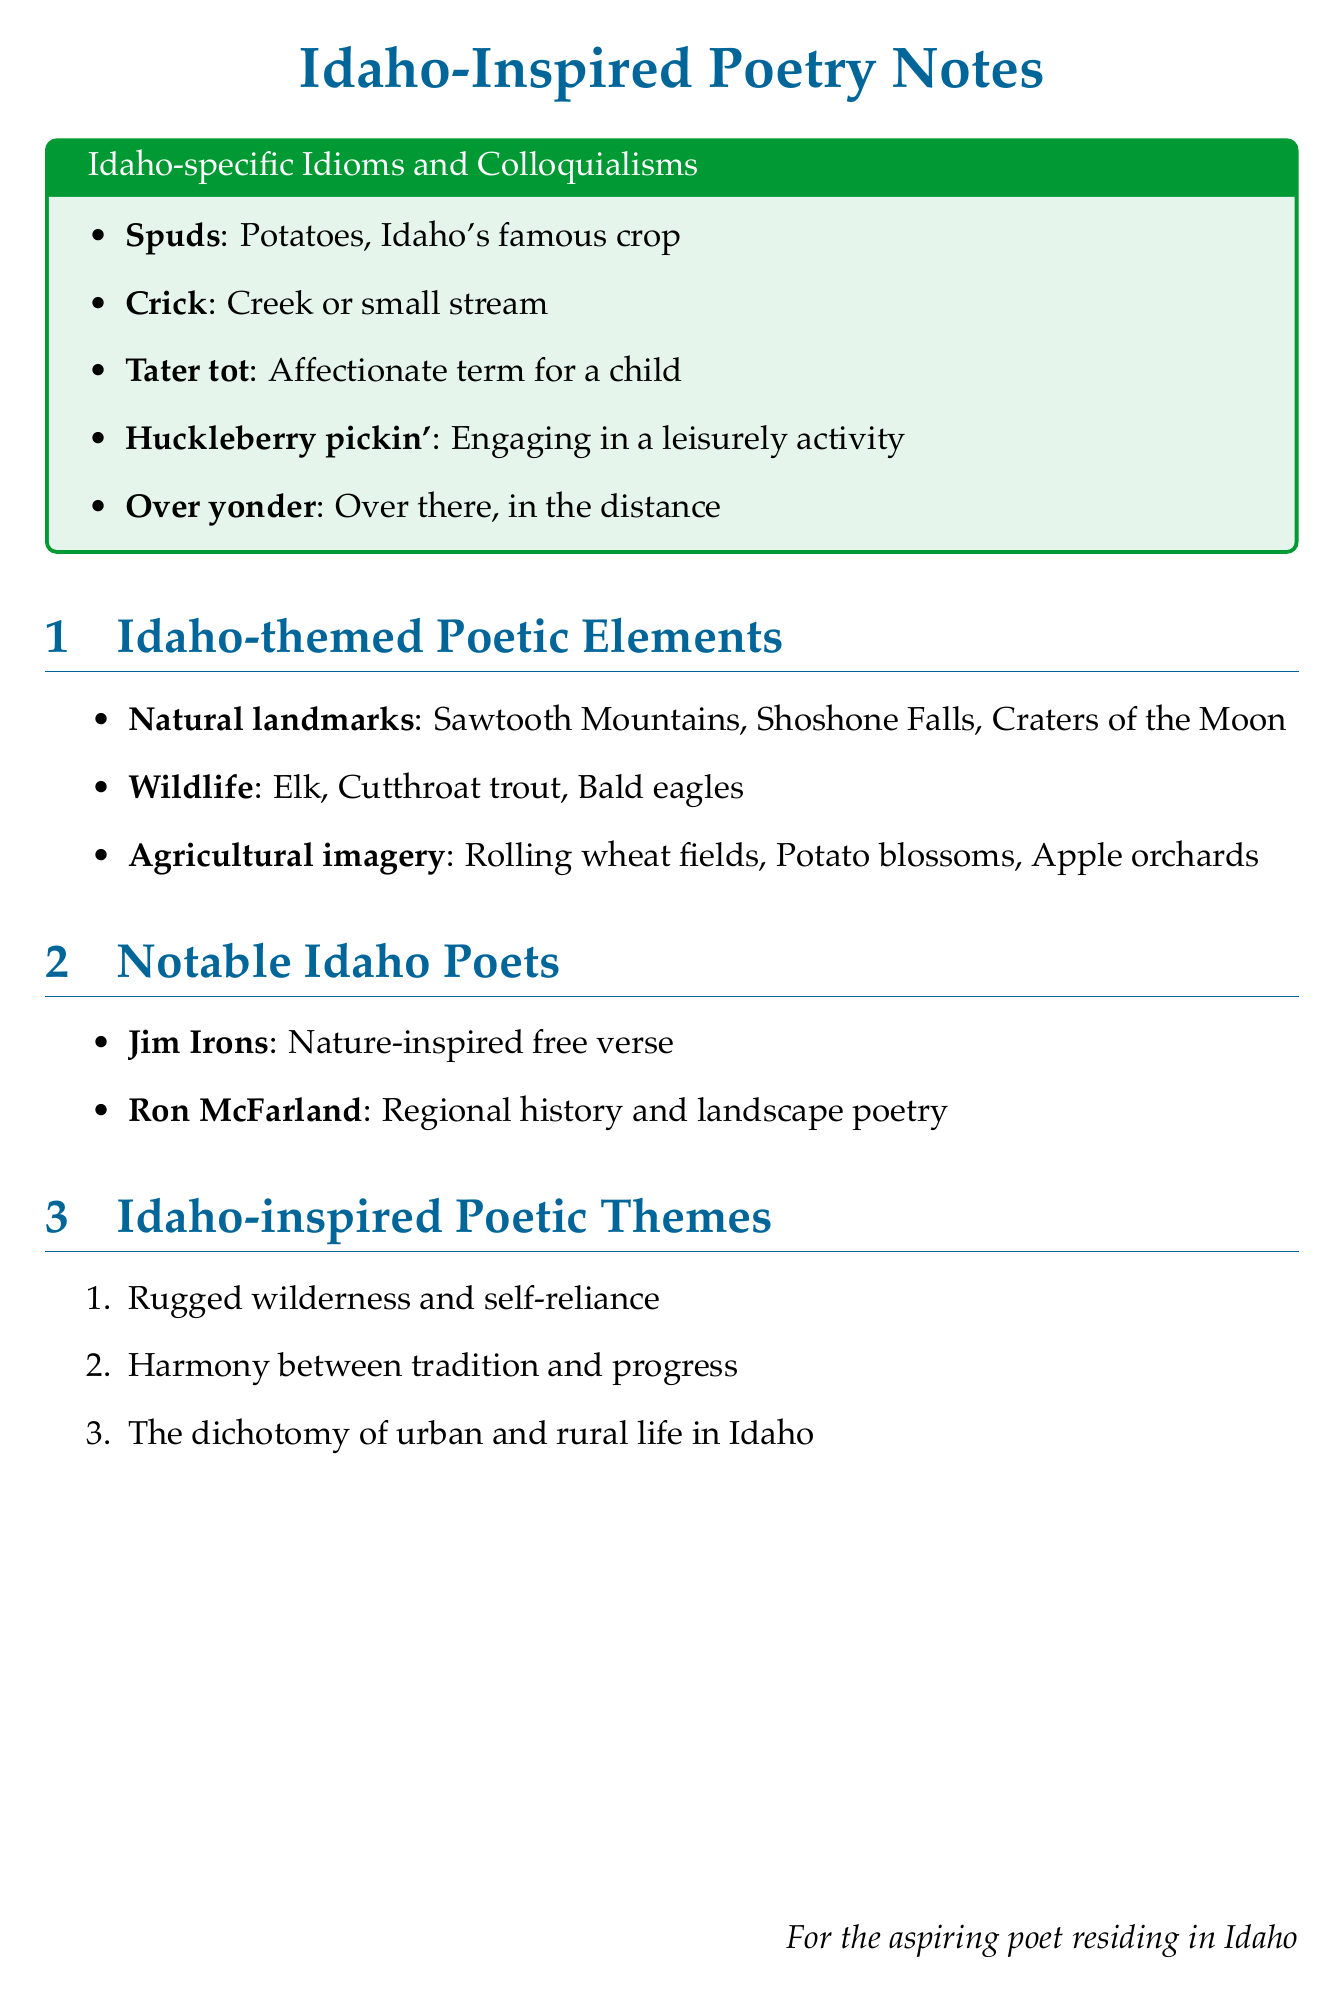What does "Spuds" refer to? "Spuds" is defined in the document as Idaho's famous crop, which is potatoes.
Answer: Potatoes What is the meaning of "Crick"? "Crick" is explained in the text as a creek or small stream.
Answer: Creek Name one of the notable Idaho poets mentioned. The document lists poets, including Jim Irons and Ron McFarland.
Answer: Jim Irons What style is Ron McFarland known for? The document states that Ron McFarland's style is regional history and landscape poetry.
Answer: Regional history and landscape poetry What are "Huckleberry pickin'" activities characterized as? "Huckleberry pickin'" is described as engaging in a leisurely activity in the document.
Answer: Engaging in a leisurely activity What is one of the themes of Idaho-inspired poetry? The document outlines several themes, including rugged wilderness and self-reliance.
Answer: Rugged wilderness and self-reliance List an example of Idaho wildlife mentioned. The wildlife section in the document provides examples, such as elk and cutthroat trout.
Answer: Elk How many idioms or colloquialisms are mentioned? There are five Idaho-specific idioms and colloquialisms listed in the document.
Answer: Five 